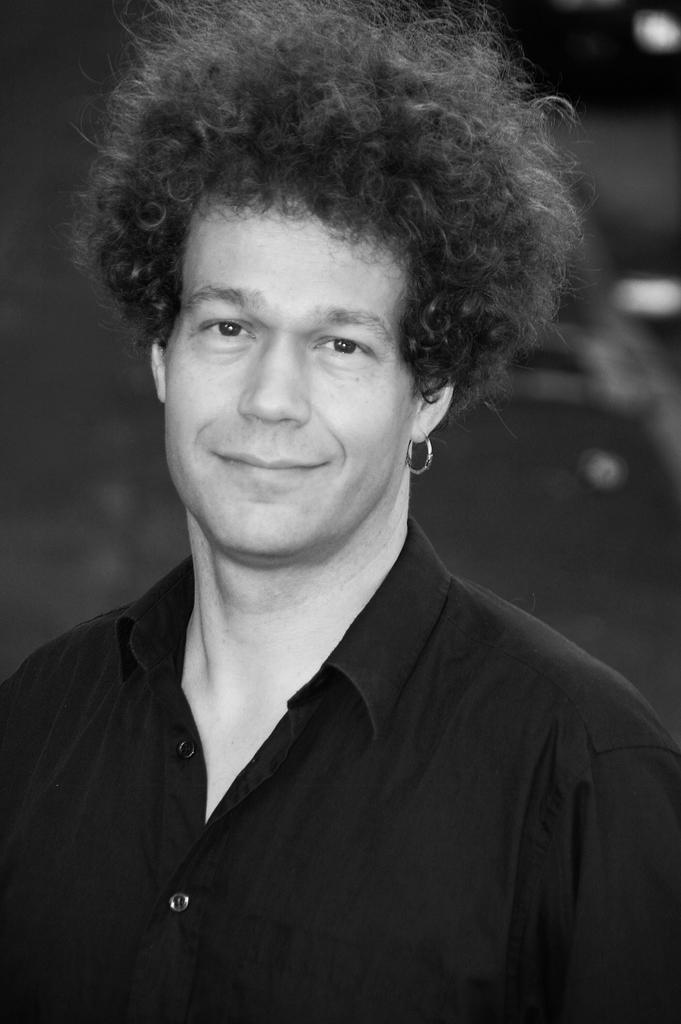Please provide a concise description of this image. In this image we can see a man smiling. 